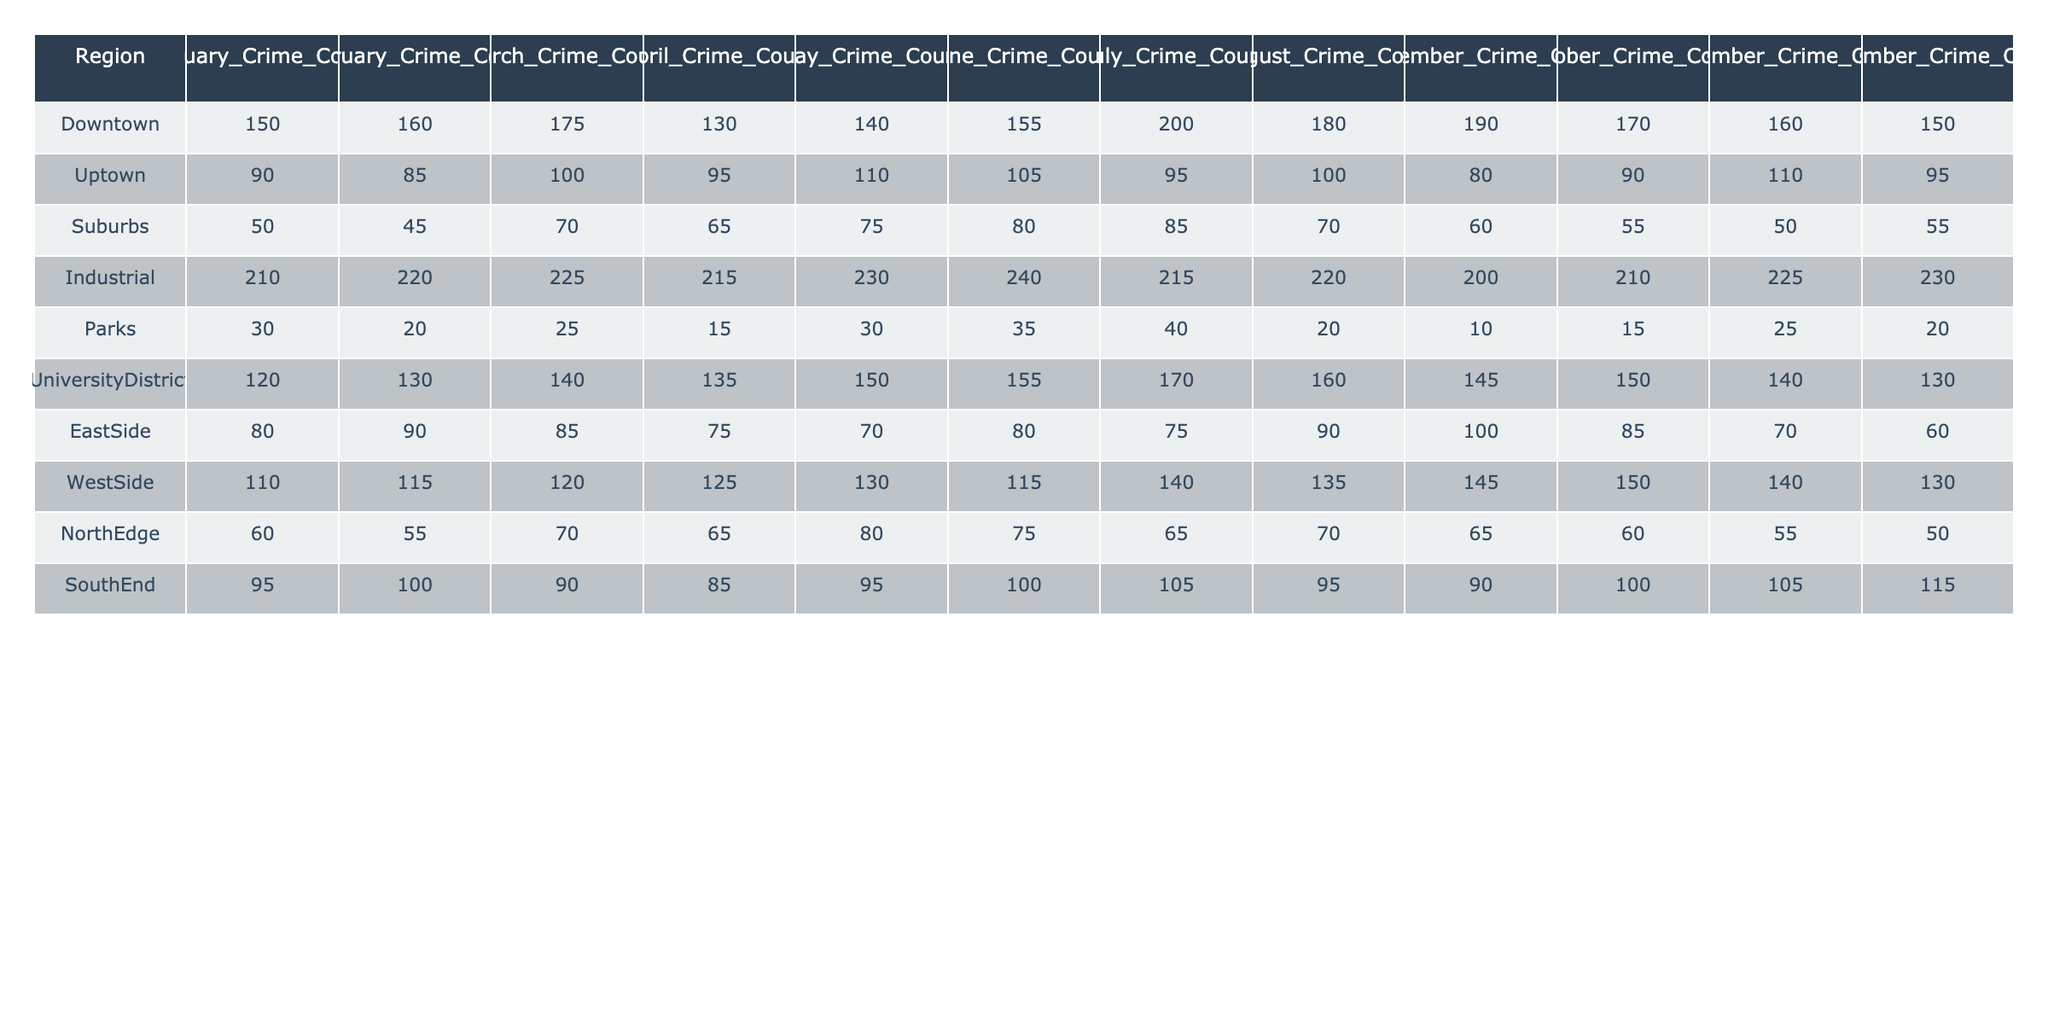What is the total crime count in the Industrial region over the year? To find the total crime count in the Industrial region, we sum the monthly counts: 210 + 220 + 225 + 215 + 230 + 240 + 215 + 220 + 200 + 210 + 225 + 230 = 2,670.
Answer: 2670 Which region had the highest total crime count in July? Looking at the July counts, Downtown had 200, Industrial had 215, Parks had 40, University District had 170, East Side had 75, West Side had 140, North Edge had 65, and South End had 105. The highest crime count is from Industrial at 215.
Answer: Industrial What is the average crime count for the Uptown region over the year? To calculate the average for Uptown, we sum the counts: 90 + 85 + 100 + 95 + 110 + 105 + 95 + 100 + 80 + 90 + 110 + 95 = 1,195. Dividing by 12 months gives us an average of 1,195 / 12 = 99.58, which rounds to 100.
Answer: 100 Did the crime count in the Parks region increase from January to December? The January count was 30 and the December count was 20. Since 20 is less than 30, the crime count decreased.
Answer: No Which month had the highest overall crime count across all regions? By adding the monthly crime counts for each month: January (150 + 90 + 50 + 210 + 30 + 120 + 80 + 110 + 60 + 95) = 1,095; February (160 + 85 + 45 + 220 + 20 + 130 + 90 + 115 + 55 + 100) = 1,095; March has a count of 1,130; April is 1,045; May is 1,090; June is 1,130; July is 1,045; August is 1,035; September is 1,130; October is 1,090; November is 1,045; December is 1,045. The highest is March and June, each with 1,130.
Answer: March and June What is the difference in crime counts between Downtown and South End in November? Downtown's November count is 160, and South End's is 105. The difference is 160 - 105 = 55.
Answer: 55 What is the total number of crimes reported in the University District for the summer months (June, July, August)? The counts for the summer months are June (155), July (170), and August (160). Summing these gives 155 + 170 + 160 = 485.
Answer: 485 Which region experienced the greatest increase in crime count from January to April? We observe the changes: Downtown increased from 150 to 130 (decrease of 20), Uptown from 90 to 95 (increase of 5), Suburbs from 50 to 65 (increase of 15), Industrial from 210 to 215 (increase of 5), Parks from 30 to 15 (decrease of 15), University District from 120 to 135 (increase of 15), East Side from 80 to 75 (decrease of 5), West Side from 110 to 125 (increase of 15), North Edge from 60 to 65 (increase of 5), South End from 95 to 85 (decrease of 10). The greatest increase is in Suburbs, University District, and West Side at 15 each.
Answer: Suburbs, University District, and West Side Is the total crime count for the WestSide region greater than that for the NorthEdge region across the entire year? The total for WestSide is 1,620 (sum of all months) while NorthEdge's total is 735. Since 1,620 is greater than 735, the statement is true.
Answer: Yes What was the trend in crime counts in the East Side region from January to December? The counts show a decrease from 80 in January to 60 in December, with fluctuations in between. The overall trend is decreasing.
Answer: Decreasing 